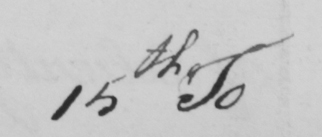What text is written in this handwritten line? 15th To 